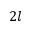Convert formula to latex. <formula><loc_0><loc_0><loc_500><loc_500>2 l</formula> 